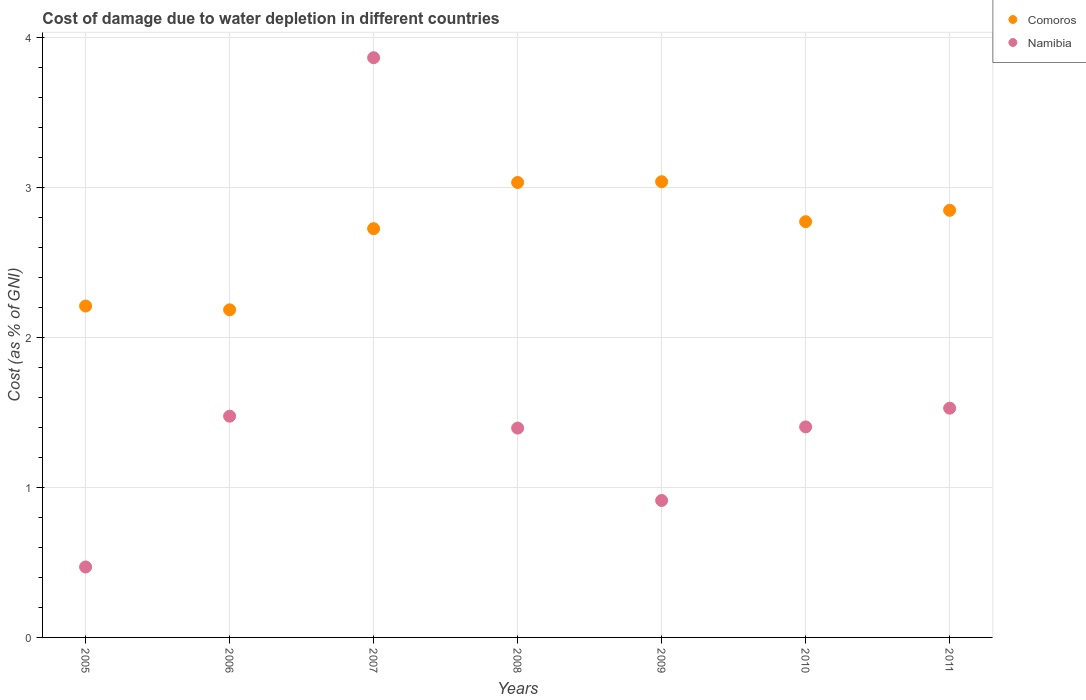How many different coloured dotlines are there?
Make the answer very short. 2. What is the cost of damage caused due to water depletion in Comoros in 2010?
Make the answer very short. 2.77. Across all years, what is the maximum cost of damage caused due to water depletion in Comoros?
Make the answer very short. 3.04. Across all years, what is the minimum cost of damage caused due to water depletion in Namibia?
Provide a short and direct response. 0.47. In which year was the cost of damage caused due to water depletion in Comoros maximum?
Your answer should be compact. 2009. In which year was the cost of damage caused due to water depletion in Comoros minimum?
Your answer should be very brief. 2006. What is the total cost of damage caused due to water depletion in Namibia in the graph?
Keep it short and to the point. 11.05. What is the difference between the cost of damage caused due to water depletion in Namibia in 2006 and that in 2011?
Give a very brief answer. -0.05. What is the difference between the cost of damage caused due to water depletion in Comoros in 2011 and the cost of damage caused due to water depletion in Namibia in 2009?
Give a very brief answer. 1.94. What is the average cost of damage caused due to water depletion in Comoros per year?
Your response must be concise. 2.69. In the year 2005, what is the difference between the cost of damage caused due to water depletion in Namibia and cost of damage caused due to water depletion in Comoros?
Ensure brevity in your answer.  -1.74. In how many years, is the cost of damage caused due to water depletion in Namibia greater than 0.4 %?
Give a very brief answer. 7. What is the ratio of the cost of damage caused due to water depletion in Comoros in 2005 to that in 2010?
Offer a very short reply. 0.8. Is the cost of damage caused due to water depletion in Comoros in 2005 less than that in 2009?
Your response must be concise. Yes. What is the difference between the highest and the second highest cost of damage caused due to water depletion in Comoros?
Provide a short and direct response. 0.01. What is the difference between the highest and the lowest cost of damage caused due to water depletion in Namibia?
Give a very brief answer. 3.4. Is the sum of the cost of damage caused due to water depletion in Comoros in 2006 and 2007 greater than the maximum cost of damage caused due to water depletion in Namibia across all years?
Offer a terse response. Yes. Does the cost of damage caused due to water depletion in Comoros monotonically increase over the years?
Keep it short and to the point. No. Is the cost of damage caused due to water depletion in Namibia strictly greater than the cost of damage caused due to water depletion in Comoros over the years?
Keep it short and to the point. No. Are the values on the major ticks of Y-axis written in scientific E-notation?
Make the answer very short. No. Where does the legend appear in the graph?
Your answer should be compact. Top right. What is the title of the graph?
Provide a succinct answer. Cost of damage due to water depletion in different countries. Does "Bahrain" appear as one of the legend labels in the graph?
Provide a short and direct response. No. What is the label or title of the Y-axis?
Offer a terse response. Cost (as % of GNI). What is the Cost (as % of GNI) of Comoros in 2005?
Offer a very short reply. 2.21. What is the Cost (as % of GNI) in Namibia in 2005?
Offer a terse response. 0.47. What is the Cost (as % of GNI) of Comoros in 2006?
Your answer should be very brief. 2.18. What is the Cost (as % of GNI) of Namibia in 2006?
Your response must be concise. 1.48. What is the Cost (as % of GNI) in Comoros in 2007?
Give a very brief answer. 2.73. What is the Cost (as % of GNI) of Namibia in 2007?
Your answer should be compact. 3.87. What is the Cost (as % of GNI) in Comoros in 2008?
Keep it short and to the point. 3.03. What is the Cost (as % of GNI) in Namibia in 2008?
Offer a terse response. 1.4. What is the Cost (as % of GNI) in Comoros in 2009?
Keep it short and to the point. 3.04. What is the Cost (as % of GNI) of Namibia in 2009?
Keep it short and to the point. 0.91. What is the Cost (as % of GNI) in Comoros in 2010?
Offer a very short reply. 2.77. What is the Cost (as % of GNI) in Namibia in 2010?
Your answer should be very brief. 1.4. What is the Cost (as % of GNI) in Comoros in 2011?
Your answer should be compact. 2.85. What is the Cost (as % of GNI) of Namibia in 2011?
Make the answer very short. 1.53. Across all years, what is the maximum Cost (as % of GNI) in Comoros?
Your response must be concise. 3.04. Across all years, what is the maximum Cost (as % of GNI) in Namibia?
Your answer should be compact. 3.87. Across all years, what is the minimum Cost (as % of GNI) in Comoros?
Give a very brief answer. 2.18. Across all years, what is the minimum Cost (as % of GNI) in Namibia?
Offer a very short reply. 0.47. What is the total Cost (as % of GNI) of Comoros in the graph?
Your answer should be compact. 18.82. What is the total Cost (as % of GNI) of Namibia in the graph?
Your response must be concise. 11.05. What is the difference between the Cost (as % of GNI) in Comoros in 2005 and that in 2006?
Offer a very short reply. 0.03. What is the difference between the Cost (as % of GNI) of Namibia in 2005 and that in 2006?
Give a very brief answer. -1.01. What is the difference between the Cost (as % of GNI) of Comoros in 2005 and that in 2007?
Offer a terse response. -0.52. What is the difference between the Cost (as % of GNI) of Namibia in 2005 and that in 2007?
Offer a very short reply. -3.4. What is the difference between the Cost (as % of GNI) of Comoros in 2005 and that in 2008?
Ensure brevity in your answer.  -0.82. What is the difference between the Cost (as % of GNI) in Namibia in 2005 and that in 2008?
Keep it short and to the point. -0.93. What is the difference between the Cost (as % of GNI) in Comoros in 2005 and that in 2009?
Make the answer very short. -0.83. What is the difference between the Cost (as % of GNI) of Namibia in 2005 and that in 2009?
Give a very brief answer. -0.44. What is the difference between the Cost (as % of GNI) of Comoros in 2005 and that in 2010?
Your response must be concise. -0.56. What is the difference between the Cost (as % of GNI) in Namibia in 2005 and that in 2010?
Provide a succinct answer. -0.93. What is the difference between the Cost (as % of GNI) in Comoros in 2005 and that in 2011?
Offer a very short reply. -0.64. What is the difference between the Cost (as % of GNI) in Namibia in 2005 and that in 2011?
Keep it short and to the point. -1.06. What is the difference between the Cost (as % of GNI) of Comoros in 2006 and that in 2007?
Ensure brevity in your answer.  -0.54. What is the difference between the Cost (as % of GNI) in Namibia in 2006 and that in 2007?
Give a very brief answer. -2.39. What is the difference between the Cost (as % of GNI) in Comoros in 2006 and that in 2008?
Provide a succinct answer. -0.85. What is the difference between the Cost (as % of GNI) of Namibia in 2006 and that in 2008?
Ensure brevity in your answer.  0.08. What is the difference between the Cost (as % of GNI) of Comoros in 2006 and that in 2009?
Make the answer very short. -0.85. What is the difference between the Cost (as % of GNI) of Namibia in 2006 and that in 2009?
Offer a very short reply. 0.56. What is the difference between the Cost (as % of GNI) in Comoros in 2006 and that in 2010?
Give a very brief answer. -0.59. What is the difference between the Cost (as % of GNI) of Namibia in 2006 and that in 2010?
Provide a succinct answer. 0.07. What is the difference between the Cost (as % of GNI) of Comoros in 2006 and that in 2011?
Keep it short and to the point. -0.66. What is the difference between the Cost (as % of GNI) of Namibia in 2006 and that in 2011?
Ensure brevity in your answer.  -0.05. What is the difference between the Cost (as % of GNI) in Comoros in 2007 and that in 2008?
Your answer should be compact. -0.31. What is the difference between the Cost (as % of GNI) in Namibia in 2007 and that in 2008?
Provide a succinct answer. 2.47. What is the difference between the Cost (as % of GNI) of Comoros in 2007 and that in 2009?
Give a very brief answer. -0.31. What is the difference between the Cost (as % of GNI) in Namibia in 2007 and that in 2009?
Ensure brevity in your answer.  2.95. What is the difference between the Cost (as % of GNI) of Comoros in 2007 and that in 2010?
Your answer should be compact. -0.05. What is the difference between the Cost (as % of GNI) in Namibia in 2007 and that in 2010?
Provide a short and direct response. 2.46. What is the difference between the Cost (as % of GNI) in Comoros in 2007 and that in 2011?
Offer a very short reply. -0.12. What is the difference between the Cost (as % of GNI) of Namibia in 2007 and that in 2011?
Your answer should be very brief. 2.34. What is the difference between the Cost (as % of GNI) in Comoros in 2008 and that in 2009?
Give a very brief answer. -0.01. What is the difference between the Cost (as % of GNI) in Namibia in 2008 and that in 2009?
Provide a succinct answer. 0.48. What is the difference between the Cost (as % of GNI) in Comoros in 2008 and that in 2010?
Give a very brief answer. 0.26. What is the difference between the Cost (as % of GNI) of Namibia in 2008 and that in 2010?
Offer a very short reply. -0.01. What is the difference between the Cost (as % of GNI) in Comoros in 2008 and that in 2011?
Ensure brevity in your answer.  0.19. What is the difference between the Cost (as % of GNI) in Namibia in 2008 and that in 2011?
Offer a terse response. -0.13. What is the difference between the Cost (as % of GNI) in Comoros in 2009 and that in 2010?
Ensure brevity in your answer.  0.27. What is the difference between the Cost (as % of GNI) in Namibia in 2009 and that in 2010?
Your answer should be very brief. -0.49. What is the difference between the Cost (as % of GNI) of Comoros in 2009 and that in 2011?
Your response must be concise. 0.19. What is the difference between the Cost (as % of GNI) in Namibia in 2009 and that in 2011?
Give a very brief answer. -0.62. What is the difference between the Cost (as % of GNI) in Comoros in 2010 and that in 2011?
Offer a very short reply. -0.08. What is the difference between the Cost (as % of GNI) in Namibia in 2010 and that in 2011?
Make the answer very short. -0.12. What is the difference between the Cost (as % of GNI) of Comoros in 2005 and the Cost (as % of GNI) of Namibia in 2006?
Give a very brief answer. 0.73. What is the difference between the Cost (as % of GNI) in Comoros in 2005 and the Cost (as % of GNI) in Namibia in 2007?
Make the answer very short. -1.66. What is the difference between the Cost (as % of GNI) in Comoros in 2005 and the Cost (as % of GNI) in Namibia in 2008?
Ensure brevity in your answer.  0.81. What is the difference between the Cost (as % of GNI) of Comoros in 2005 and the Cost (as % of GNI) of Namibia in 2009?
Offer a very short reply. 1.3. What is the difference between the Cost (as % of GNI) in Comoros in 2005 and the Cost (as % of GNI) in Namibia in 2010?
Your response must be concise. 0.81. What is the difference between the Cost (as % of GNI) in Comoros in 2005 and the Cost (as % of GNI) in Namibia in 2011?
Your response must be concise. 0.68. What is the difference between the Cost (as % of GNI) of Comoros in 2006 and the Cost (as % of GNI) of Namibia in 2007?
Your answer should be very brief. -1.68. What is the difference between the Cost (as % of GNI) in Comoros in 2006 and the Cost (as % of GNI) in Namibia in 2008?
Give a very brief answer. 0.79. What is the difference between the Cost (as % of GNI) in Comoros in 2006 and the Cost (as % of GNI) in Namibia in 2009?
Provide a short and direct response. 1.27. What is the difference between the Cost (as % of GNI) in Comoros in 2006 and the Cost (as % of GNI) in Namibia in 2010?
Provide a short and direct response. 0.78. What is the difference between the Cost (as % of GNI) of Comoros in 2006 and the Cost (as % of GNI) of Namibia in 2011?
Keep it short and to the point. 0.66. What is the difference between the Cost (as % of GNI) of Comoros in 2007 and the Cost (as % of GNI) of Namibia in 2008?
Your answer should be very brief. 1.33. What is the difference between the Cost (as % of GNI) in Comoros in 2007 and the Cost (as % of GNI) in Namibia in 2009?
Provide a short and direct response. 1.81. What is the difference between the Cost (as % of GNI) of Comoros in 2007 and the Cost (as % of GNI) of Namibia in 2010?
Keep it short and to the point. 1.32. What is the difference between the Cost (as % of GNI) in Comoros in 2007 and the Cost (as % of GNI) in Namibia in 2011?
Offer a terse response. 1.2. What is the difference between the Cost (as % of GNI) in Comoros in 2008 and the Cost (as % of GNI) in Namibia in 2009?
Ensure brevity in your answer.  2.12. What is the difference between the Cost (as % of GNI) in Comoros in 2008 and the Cost (as % of GNI) in Namibia in 2010?
Provide a succinct answer. 1.63. What is the difference between the Cost (as % of GNI) in Comoros in 2008 and the Cost (as % of GNI) in Namibia in 2011?
Give a very brief answer. 1.51. What is the difference between the Cost (as % of GNI) in Comoros in 2009 and the Cost (as % of GNI) in Namibia in 2010?
Offer a terse response. 1.64. What is the difference between the Cost (as % of GNI) in Comoros in 2009 and the Cost (as % of GNI) in Namibia in 2011?
Ensure brevity in your answer.  1.51. What is the difference between the Cost (as % of GNI) of Comoros in 2010 and the Cost (as % of GNI) of Namibia in 2011?
Your response must be concise. 1.24. What is the average Cost (as % of GNI) of Comoros per year?
Your response must be concise. 2.69. What is the average Cost (as % of GNI) in Namibia per year?
Provide a succinct answer. 1.58. In the year 2005, what is the difference between the Cost (as % of GNI) of Comoros and Cost (as % of GNI) of Namibia?
Your response must be concise. 1.74. In the year 2006, what is the difference between the Cost (as % of GNI) of Comoros and Cost (as % of GNI) of Namibia?
Offer a terse response. 0.71. In the year 2007, what is the difference between the Cost (as % of GNI) in Comoros and Cost (as % of GNI) in Namibia?
Give a very brief answer. -1.14. In the year 2008, what is the difference between the Cost (as % of GNI) of Comoros and Cost (as % of GNI) of Namibia?
Offer a terse response. 1.64. In the year 2009, what is the difference between the Cost (as % of GNI) of Comoros and Cost (as % of GNI) of Namibia?
Your response must be concise. 2.13. In the year 2010, what is the difference between the Cost (as % of GNI) of Comoros and Cost (as % of GNI) of Namibia?
Ensure brevity in your answer.  1.37. In the year 2011, what is the difference between the Cost (as % of GNI) of Comoros and Cost (as % of GNI) of Namibia?
Your answer should be very brief. 1.32. What is the ratio of the Cost (as % of GNI) of Comoros in 2005 to that in 2006?
Make the answer very short. 1.01. What is the ratio of the Cost (as % of GNI) of Namibia in 2005 to that in 2006?
Keep it short and to the point. 0.32. What is the ratio of the Cost (as % of GNI) in Comoros in 2005 to that in 2007?
Keep it short and to the point. 0.81. What is the ratio of the Cost (as % of GNI) in Namibia in 2005 to that in 2007?
Your answer should be compact. 0.12. What is the ratio of the Cost (as % of GNI) in Comoros in 2005 to that in 2008?
Your answer should be compact. 0.73. What is the ratio of the Cost (as % of GNI) of Namibia in 2005 to that in 2008?
Your answer should be compact. 0.34. What is the ratio of the Cost (as % of GNI) in Comoros in 2005 to that in 2009?
Offer a very short reply. 0.73. What is the ratio of the Cost (as % of GNI) of Namibia in 2005 to that in 2009?
Ensure brevity in your answer.  0.51. What is the ratio of the Cost (as % of GNI) in Comoros in 2005 to that in 2010?
Give a very brief answer. 0.8. What is the ratio of the Cost (as % of GNI) of Namibia in 2005 to that in 2010?
Ensure brevity in your answer.  0.33. What is the ratio of the Cost (as % of GNI) of Comoros in 2005 to that in 2011?
Make the answer very short. 0.78. What is the ratio of the Cost (as % of GNI) of Namibia in 2005 to that in 2011?
Provide a short and direct response. 0.31. What is the ratio of the Cost (as % of GNI) in Comoros in 2006 to that in 2007?
Offer a very short reply. 0.8. What is the ratio of the Cost (as % of GNI) of Namibia in 2006 to that in 2007?
Your answer should be very brief. 0.38. What is the ratio of the Cost (as % of GNI) in Comoros in 2006 to that in 2008?
Provide a short and direct response. 0.72. What is the ratio of the Cost (as % of GNI) of Namibia in 2006 to that in 2008?
Give a very brief answer. 1.06. What is the ratio of the Cost (as % of GNI) in Comoros in 2006 to that in 2009?
Provide a short and direct response. 0.72. What is the ratio of the Cost (as % of GNI) of Namibia in 2006 to that in 2009?
Offer a terse response. 1.62. What is the ratio of the Cost (as % of GNI) in Comoros in 2006 to that in 2010?
Ensure brevity in your answer.  0.79. What is the ratio of the Cost (as % of GNI) in Namibia in 2006 to that in 2010?
Offer a very short reply. 1.05. What is the ratio of the Cost (as % of GNI) in Comoros in 2006 to that in 2011?
Your answer should be compact. 0.77. What is the ratio of the Cost (as % of GNI) of Namibia in 2006 to that in 2011?
Offer a very short reply. 0.97. What is the ratio of the Cost (as % of GNI) in Comoros in 2007 to that in 2008?
Give a very brief answer. 0.9. What is the ratio of the Cost (as % of GNI) of Namibia in 2007 to that in 2008?
Give a very brief answer. 2.77. What is the ratio of the Cost (as % of GNI) of Comoros in 2007 to that in 2009?
Make the answer very short. 0.9. What is the ratio of the Cost (as % of GNI) in Namibia in 2007 to that in 2009?
Give a very brief answer. 4.23. What is the ratio of the Cost (as % of GNI) of Comoros in 2007 to that in 2010?
Your answer should be very brief. 0.98. What is the ratio of the Cost (as % of GNI) of Namibia in 2007 to that in 2010?
Your answer should be very brief. 2.75. What is the ratio of the Cost (as % of GNI) in Comoros in 2007 to that in 2011?
Offer a very short reply. 0.96. What is the ratio of the Cost (as % of GNI) in Namibia in 2007 to that in 2011?
Your response must be concise. 2.53. What is the ratio of the Cost (as % of GNI) in Namibia in 2008 to that in 2009?
Give a very brief answer. 1.53. What is the ratio of the Cost (as % of GNI) in Comoros in 2008 to that in 2010?
Provide a succinct answer. 1.09. What is the ratio of the Cost (as % of GNI) in Namibia in 2008 to that in 2010?
Make the answer very short. 0.99. What is the ratio of the Cost (as % of GNI) in Comoros in 2008 to that in 2011?
Provide a short and direct response. 1.07. What is the ratio of the Cost (as % of GNI) in Namibia in 2008 to that in 2011?
Give a very brief answer. 0.91. What is the ratio of the Cost (as % of GNI) of Comoros in 2009 to that in 2010?
Ensure brevity in your answer.  1.1. What is the ratio of the Cost (as % of GNI) in Namibia in 2009 to that in 2010?
Your answer should be compact. 0.65. What is the ratio of the Cost (as % of GNI) of Comoros in 2009 to that in 2011?
Provide a succinct answer. 1.07. What is the ratio of the Cost (as % of GNI) in Namibia in 2009 to that in 2011?
Offer a very short reply. 0.6. What is the ratio of the Cost (as % of GNI) of Comoros in 2010 to that in 2011?
Provide a succinct answer. 0.97. What is the ratio of the Cost (as % of GNI) in Namibia in 2010 to that in 2011?
Provide a succinct answer. 0.92. What is the difference between the highest and the second highest Cost (as % of GNI) of Comoros?
Offer a terse response. 0.01. What is the difference between the highest and the second highest Cost (as % of GNI) of Namibia?
Make the answer very short. 2.34. What is the difference between the highest and the lowest Cost (as % of GNI) of Comoros?
Keep it short and to the point. 0.85. What is the difference between the highest and the lowest Cost (as % of GNI) of Namibia?
Offer a very short reply. 3.4. 